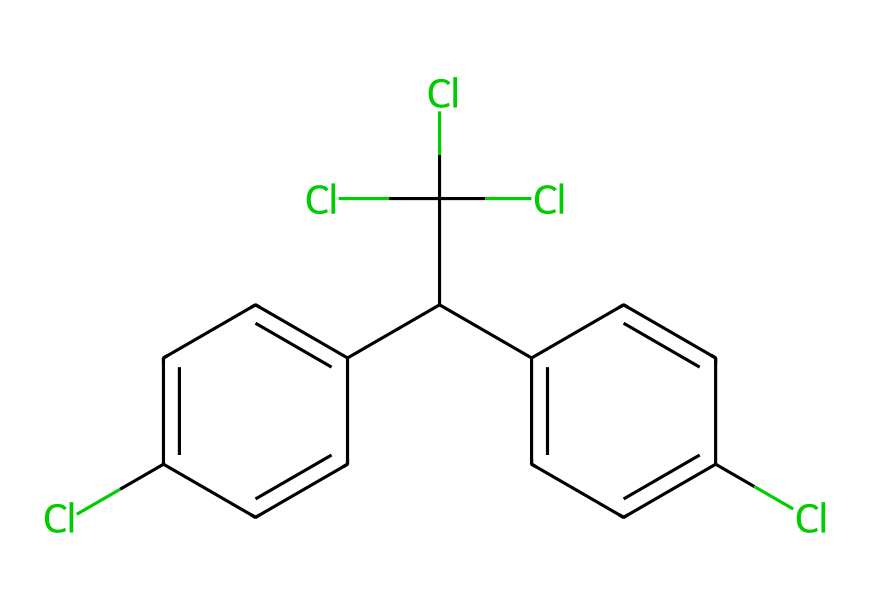What is the molecular formula of DDT? By analyzing the structure, we can count the atoms: there are 14 carbon (C) atoms, 9 hydrogen (H) atoms, and 4 chlorine (Cl) atoms. Therefore, the molecular formula can be written as C14H9Cl4.
Answer: C14H9Cl4 How many chlorine atoms are present in DDT? Reviewing the chemical structure, we see that there are four distinct chlorine atoms connected to different parts of the biphenyl.
Answer: 4 What type of chemical is DDT primarily classified as? Based on its use as a pesticide and its structural properties, particularly the presence of multiple aromatic rings and chlorine substitutions, DDT is classified as an insecticide.
Answer: insecticide What is the total number of rings in the DDT structure? Looking at the molecular structure, we can identify that there are two benzene rings that are part of the overall structure, indicating the presence of two rings.
Answer: 2 What characteristic in DDT's structure contributes to its persistence in the environment? The presence of multiple chlorine atoms and their placements leads to a stable molecular structure that is resistant to degradation, causing DDT to persist in soil and biological systems.
Answer: stability Which functional group is responsible for the hydrophobic nature of DDT? The chlorinated aromatic structure, particularly the multiple chlorine substituents, enhances its hydrophobic characteristics, limiting its solubility in water.
Answer: chlorinated aromatic 